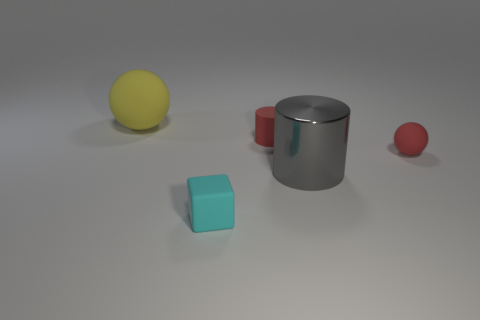What number of other objects are there of the same color as the tiny matte sphere?
Make the answer very short. 1. There is a small cylinder that is the same color as the small ball; what is its material?
Give a very brief answer. Rubber. Is there a big shiny object that has the same color as the tiny matte block?
Your response must be concise. No. Do the block and the red cylinder have the same size?
Ensure brevity in your answer.  Yes. Is the color of the large metallic cylinder the same as the tiny ball?
Your answer should be very brief. No. There is a big thing that is right of the rubber sphere behind the red rubber ball; what is its material?
Give a very brief answer. Metal. There is another thing that is the same shape as the yellow object; what material is it?
Provide a short and direct response. Rubber. There is a rubber ball left of the red matte sphere; is its size the same as the red ball?
Provide a succinct answer. No. How many shiny objects are either small red cylinders or spheres?
Your response must be concise. 0. There is a small thing that is on the left side of the gray object and behind the big metal thing; what is it made of?
Your answer should be very brief. Rubber. 